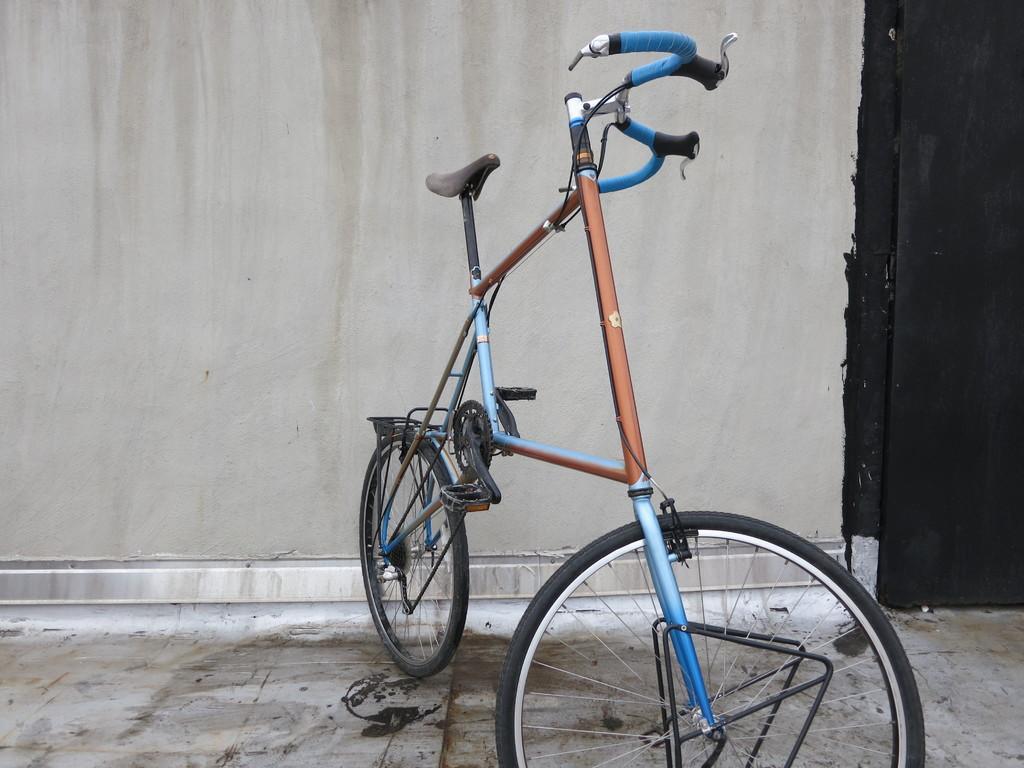Describe this image in one or two sentences. In the center of the image a bicycle is present. In the background of the image a wall and a door are present. At the bottom of the image floor is there. 